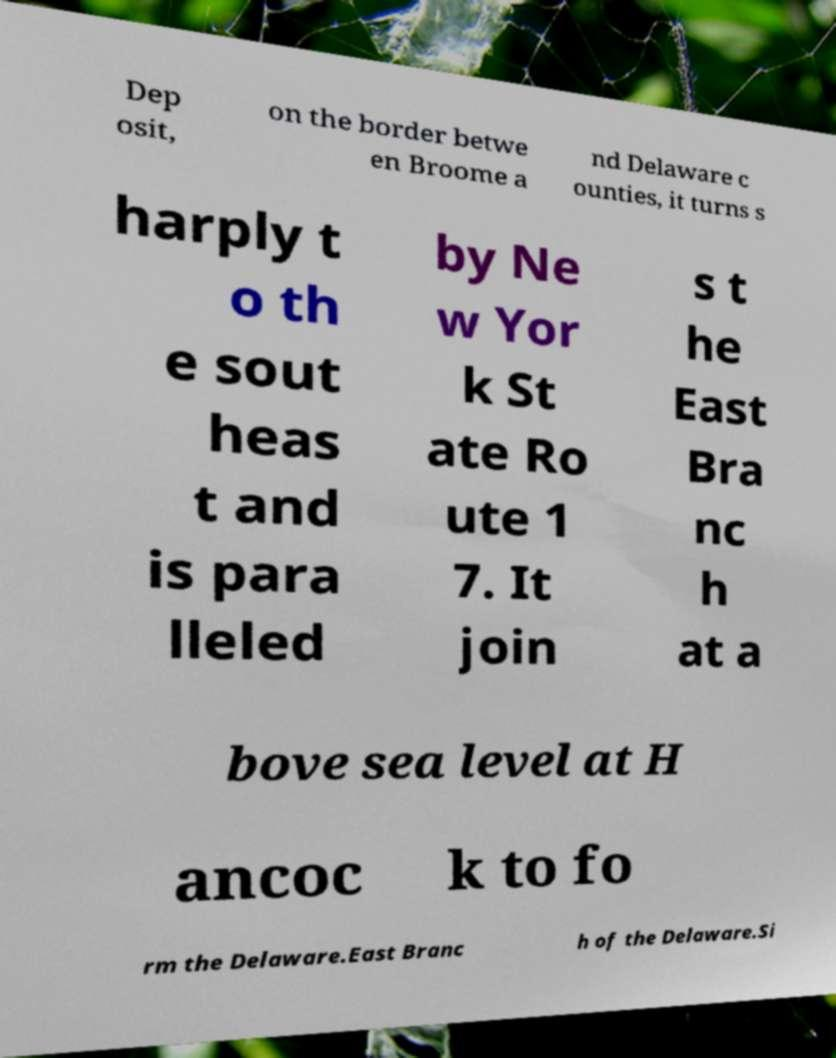Please read and relay the text visible in this image. What does it say? Dep osit, on the border betwe en Broome a nd Delaware c ounties, it turns s harply t o th e sout heas t and is para lleled by Ne w Yor k St ate Ro ute 1 7. It join s t he East Bra nc h at a bove sea level at H ancoc k to fo rm the Delaware.East Branc h of the Delaware.Si 